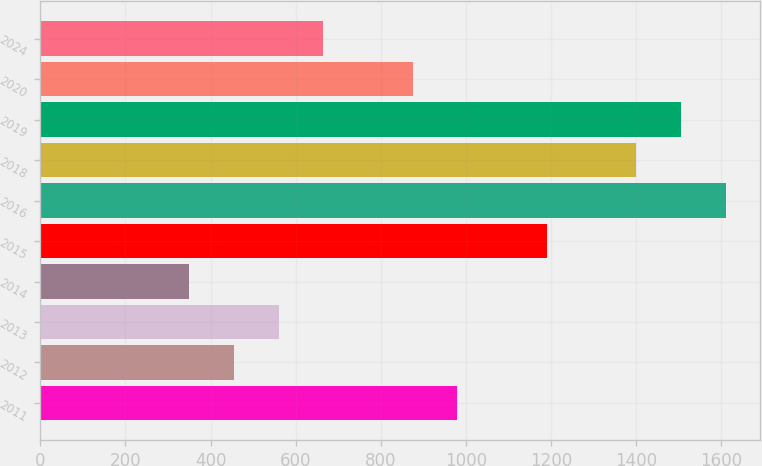Convert chart. <chart><loc_0><loc_0><loc_500><loc_500><bar_chart><fcel>2011<fcel>2012<fcel>2013<fcel>2014<fcel>2015<fcel>2016<fcel>2018<fcel>2019<fcel>2020<fcel>2024<nl><fcel>980<fcel>455<fcel>560<fcel>350<fcel>1190<fcel>1610<fcel>1400<fcel>1505<fcel>875<fcel>665<nl></chart> 